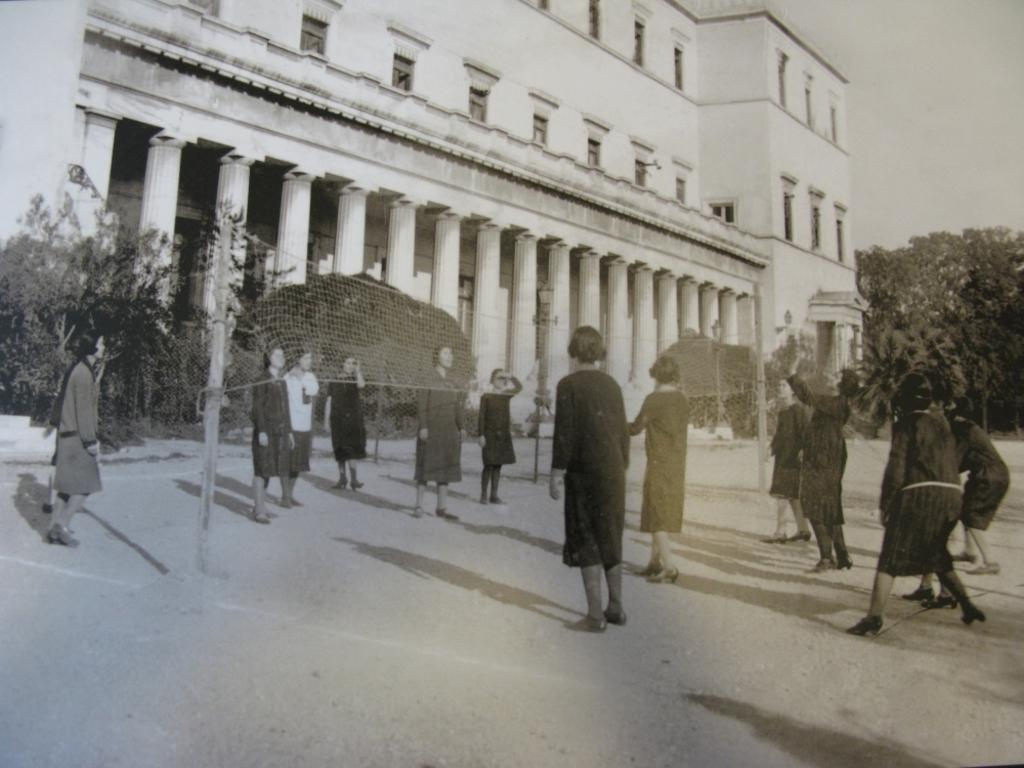What can be seen in the image? There are people standing in the image, along with a building, pillars, windows, trees, and the sky. Can you describe the building in the image? The building has pillars and windows. What is the net attached to in the image? The net is attached to poles in the image. What type of zephyr can be seen blowing through the wilderness in the image? There is no zephyr or wilderness present in the image. How many carriages are visible in the image? There are no carriages present in the image. 